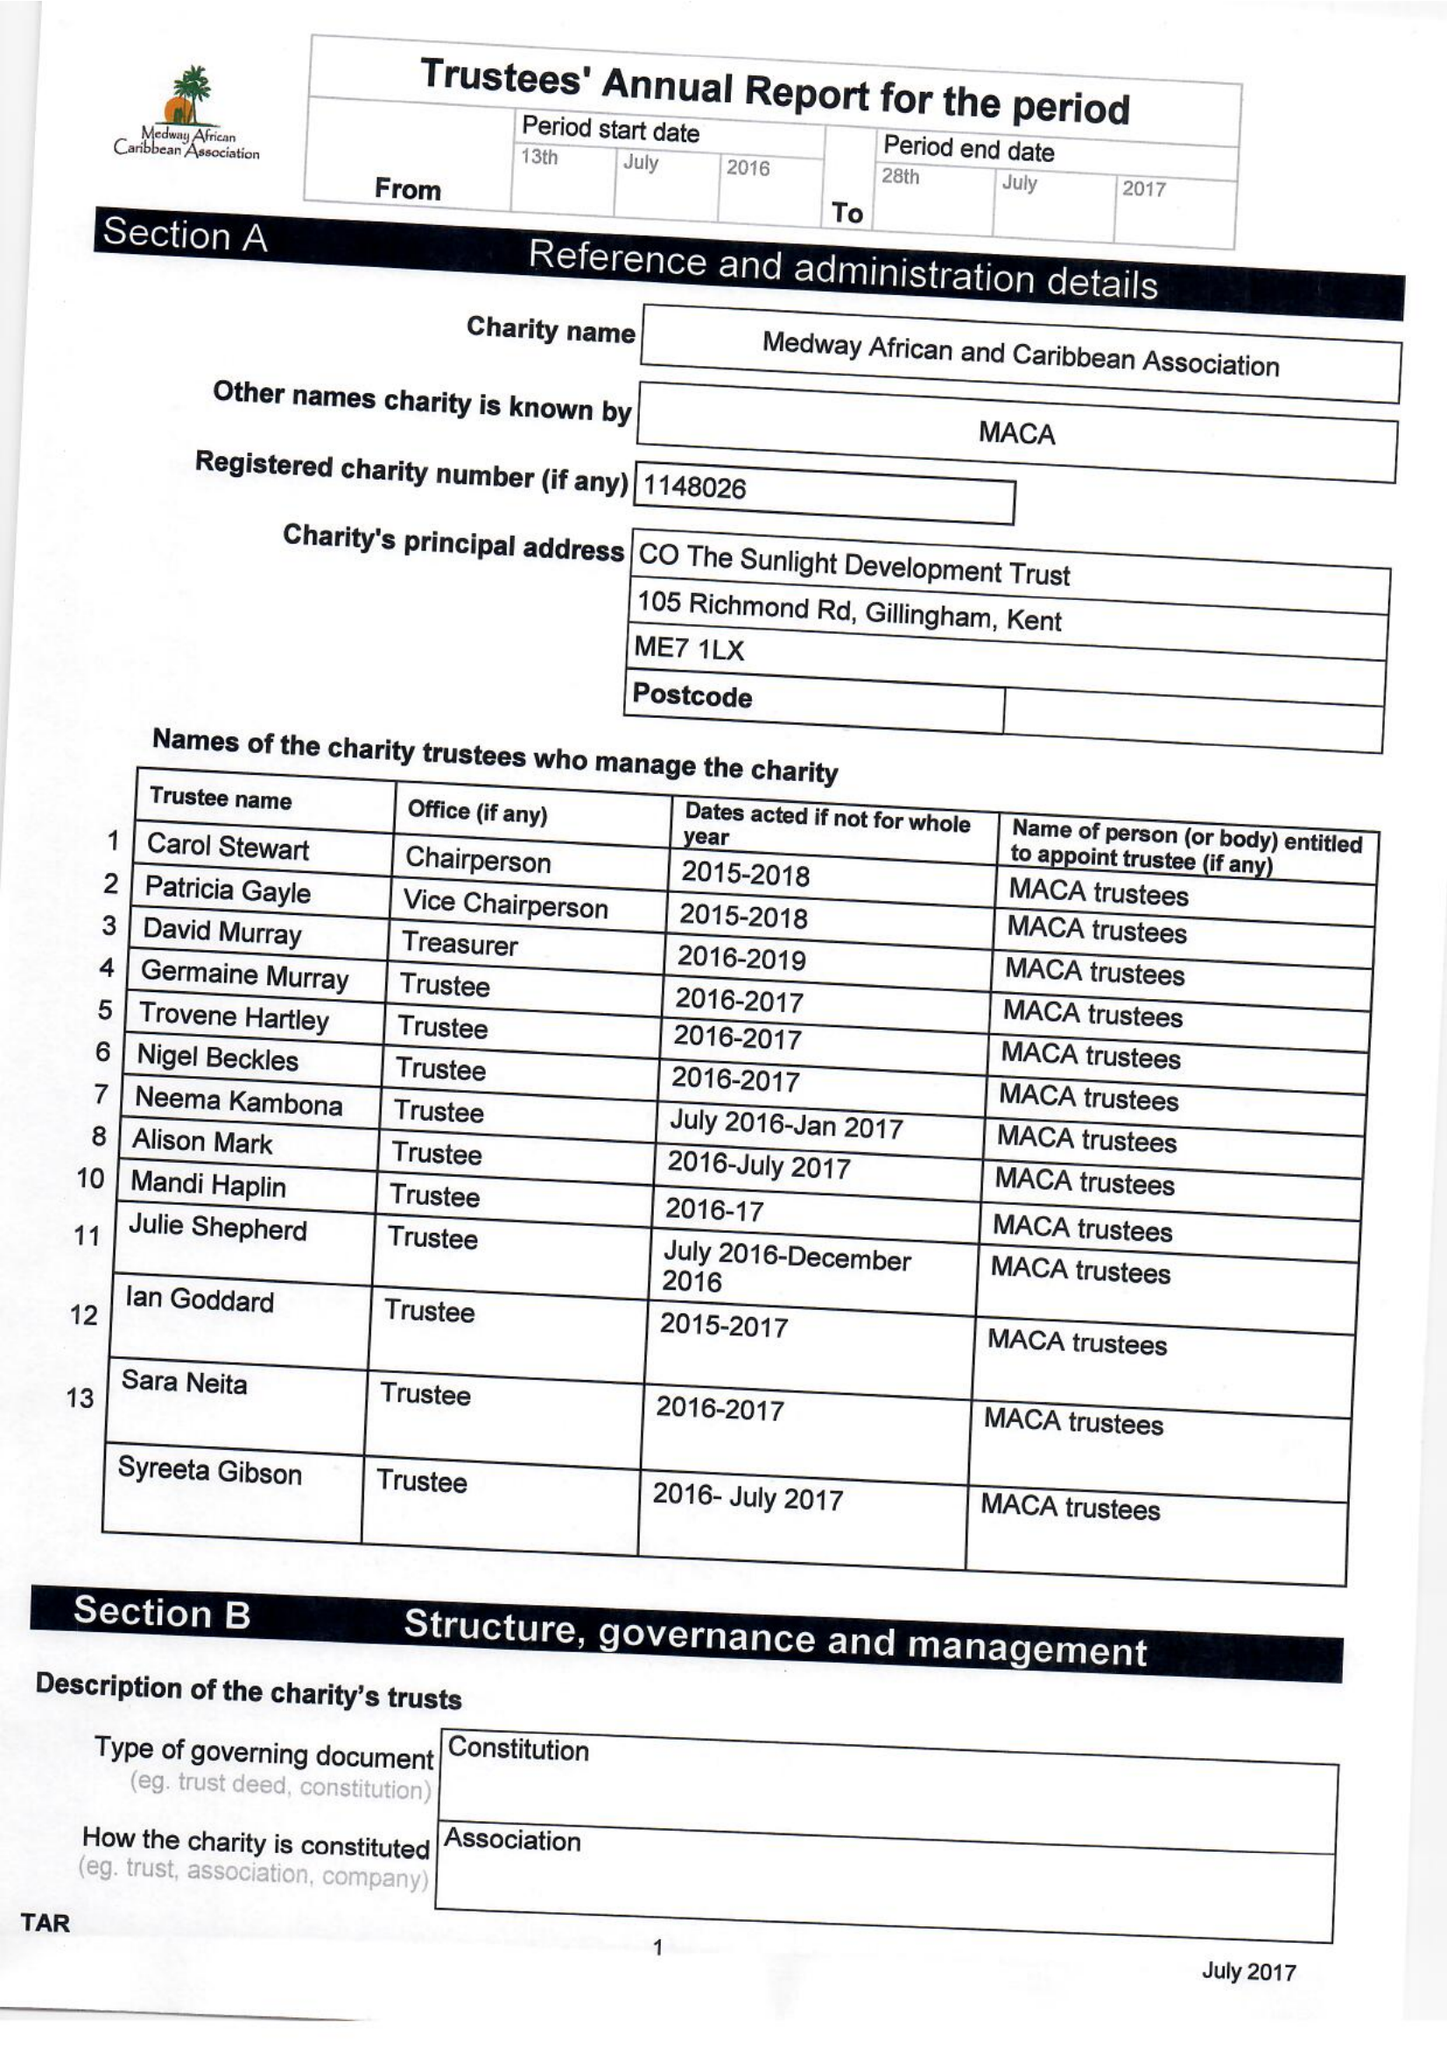What is the value for the address__street_line?
Answer the question using a single word or phrase. None 